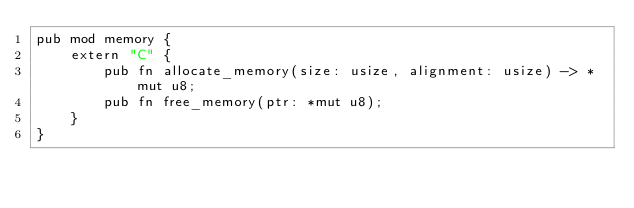<code> <loc_0><loc_0><loc_500><loc_500><_Rust_>pub mod memory {
    extern "C" {
        pub fn allocate_memory(size: usize, alignment: usize) -> *mut u8;
        pub fn free_memory(ptr: *mut u8);
    }
}
</code> 